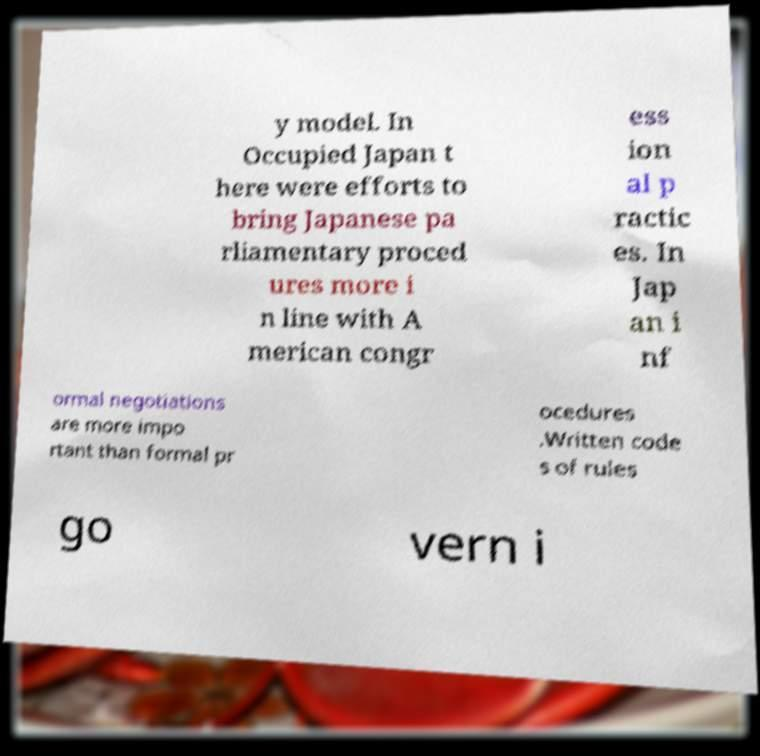I need the written content from this picture converted into text. Can you do that? y model. In Occupied Japan t here were efforts to bring Japanese pa rliamentary proced ures more i n line with A merican congr ess ion al p ractic es. In Jap an i nf ormal negotiations are more impo rtant than formal pr ocedures .Written code s of rules go vern i 